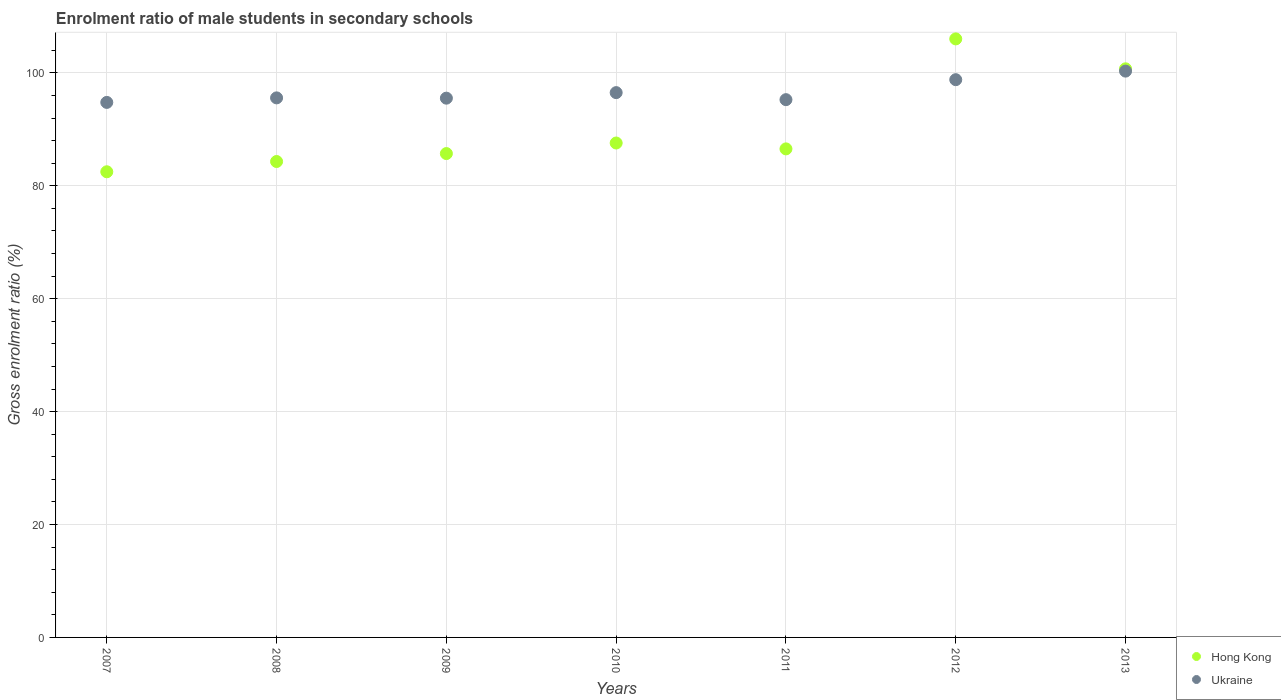Is the number of dotlines equal to the number of legend labels?
Provide a succinct answer. Yes. What is the enrolment ratio of male students in secondary schools in Hong Kong in 2007?
Keep it short and to the point. 82.49. Across all years, what is the maximum enrolment ratio of male students in secondary schools in Hong Kong?
Offer a terse response. 106.03. Across all years, what is the minimum enrolment ratio of male students in secondary schools in Hong Kong?
Give a very brief answer. 82.49. In which year was the enrolment ratio of male students in secondary schools in Hong Kong minimum?
Give a very brief answer. 2007. What is the total enrolment ratio of male students in secondary schools in Ukraine in the graph?
Provide a short and direct response. 676.79. What is the difference between the enrolment ratio of male students in secondary schools in Ukraine in 2010 and that in 2013?
Your answer should be compact. -3.81. What is the difference between the enrolment ratio of male students in secondary schools in Ukraine in 2008 and the enrolment ratio of male students in secondary schools in Hong Kong in 2010?
Give a very brief answer. 8. What is the average enrolment ratio of male students in secondary schools in Ukraine per year?
Give a very brief answer. 96.68. In the year 2010, what is the difference between the enrolment ratio of male students in secondary schools in Ukraine and enrolment ratio of male students in secondary schools in Hong Kong?
Offer a terse response. 8.93. What is the ratio of the enrolment ratio of male students in secondary schools in Hong Kong in 2009 to that in 2012?
Give a very brief answer. 0.81. Is the difference between the enrolment ratio of male students in secondary schools in Ukraine in 2008 and 2010 greater than the difference between the enrolment ratio of male students in secondary schools in Hong Kong in 2008 and 2010?
Your answer should be very brief. Yes. What is the difference between the highest and the second highest enrolment ratio of male students in secondary schools in Hong Kong?
Provide a succinct answer. 5.3. What is the difference between the highest and the lowest enrolment ratio of male students in secondary schools in Hong Kong?
Your answer should be very brief. 23.54. In how many years, is the enrolment ratio of male students in secondary schools in Hong Kong greater than the average enrolment ratio of male students in secondary schools in Hong Kong taken over all years?
Provide a short and direct response. 2. Does the enrolment ratio of male students in secondary schools in Ukraine monotonically increase over the years?
Ensure brevity in your answer.  No. Is the enrolment ratio of male students in secondary schools in Hong Kong strictly greater than the enrolment ratio of male students in secondary schools in Ukraine over the years?
Ensure brevity in your answer.  No. How many years are there in the graph?
Provide a succinct answer. 7. Does the graph contain any zero values?
Your answer should be compact. No. How are the legend labels stacked?
Give a very brief answer. Vertical. What is the title of the graph?
Give a very brief answer. Enrolment ratio of male students in secondary schools. Does "Least developed countries" appear as one of the legend labels in the graph?
Make the answer very short. No. What is the label or title of the X-axis?
Offer a terse response. Years. What is the label or title of the Y-axis?
Give a very brief answer. Gross enrolment ratio (%). What is the Gross enrolment ratio (%) in Hong Kong in 2007?
Give a very brief answer. 82.49. What is the Gross enrolment ratio (%) of Ukraine in 2007?
Provide a short and direct response. 94.78. What is the Gross enrolment ratio (%) in Hong Kong in 2008?
Offer a terse response. 84.31. What is the Gross enrolment ratio (%) of Ukraine in 2008?
Your answer should be compact. 95.58. What is the Gross enrolment ratio (%) of Hong Kong in 2009?
Make the answer very short. 85.72. What is the Gross enrolment ratio (%) of Ukraine in 2009?
Make the answer very short. 95.53. What is the Gross enrolment ratio (%) of Hong Kong in 2010?
Offer a terse response. 87.59. What is the Gross enrolment ratio (%) in Ukraine in 2010?
Offer a very short reply. 96.51. What is the Gross enrolment ratio (%) in Hong Kong in 2011?
Provide a short and direct response. 86.54. What is the Gross enrolment ratio (%) of Ukraine in 2011?
Provide a succinct answer. 95.26. What is the Gross enrolment ratio (%) of Hong Kong in 2012?
Your answer should be compact. 106.03. What is the Gross enrolment ratio (%) in Ukraine in 2012?
Provide a short and direct response. 98.8. What is the Gross enrolment ratio (%) in Hong Kong in 2013?
Ensure brevity in your answer.  100.73. What is the Gross enrolment ratio (%) of Ukraine in 2013?
Give a very brief answer. 100.32. Across all years, what is the maximum Gross enrolment ratio (%) in Hong Kong?
Provide a short and direct response. 106.03. Across all years, what is the maximum Gross enrolment ratio (%) in Ukraine?
Ensure brevity in your answer.  100.32. Across all years, what is the minimum Gross enrolment ratio (%) of Hong Kong?
Provide a succinct answer. 82.49. Across all years, what is the minimum Gross enrolment ratio (%) of Ukraine?
Your response must be concise. 94.78. What is the total Gross enrolment ratio (%) in Hong Kong in the graph?
Ensure brevity in your answer.  633.4. What is the total Gross enrolment ratio (%) in Ukraine in the graph?
Provide a succinct answer. 676.79. What is the difference between the Gross enrolment ratio (%) in Hong Kong in 2007 and that in 2008?
Give a very brief answer. -1.82. What is the difference between the Gross enrolment ratio (%) of Ukraine in 2007 and that in 2008?
Keep it short and to the point. -0.8. What is the difference between the Gross enrolment ratio (%) of Hong Kong in 2007 and that in 2009?
Ensure brevity in your answer.  -3.23. What is the difference between the Gross enrolment ratio (%) in Ukraine in 2007 and that in 2009?
Your answer should be very brief. -0.75. What is the difference between the Gross enrolment ratio (%) in Hong Kong in 2007 and that in 2010?
Give a very brief answer. -5.1. What is the difference between the Gross enrolment ratio (%) in Ukraine in 2007 and that in 2010?
Make the answer very short. -1.73. What is the difference between the Gross enrolment ratio (%) in Hong Kong in 2007 and that in 2011?
Keep it short and to the point. -4.05. What is the difference between the Gross enrolment ratio (%) in Ukraine in 2007 and that in 2011?
Make the answer very short. -0.49. What is the difference between the Gross enrolment ratio (%) in Hong Kong in 2007 and that in 2012?
Give a very brief answer. -23.54. What is the difference between the Gross enrolment ratio (%) of Ukraine in 2007 and that in 2012?
Offer a very short reply. -4.03. What is the difference between the Gross enrolment ratio (%) of Hong Kong in 2007 and that in 2013?
Your answer should be very brief. -18.24. What is the difference between the Gross enrolment ratio (%) of Ukraine in 2007 and that in 2013?
Your answer should be very brief. -5.54. What is the difference between the Gross enrolment ratio (%) of Hong Kong in 2008 and that in 2009?
Provide a short and direct response. -1.41. What is the difference between the Gross enrolment ratio (%) in Ukraine in 2008 and that in 2009?
Provide a succinct answer. 0.05. What is the difference between the Gross enrolment ratio (%) of Hong Kong in 2008 and that in 2010?
Give a very brief answer. -3.28. What is the difference between the Gross enrolment ratio (%) of Ukraine in 2008 and that in 2010?
Offer a very short reply. -0.93. What is the difference between the Gross enrolment ratio (%) of Hong Kong in 2008 and that in 2011?
Your answer should be very brief. -2.24. What is the difference between the Gross enrolment ratio (%) in Ukraine in 2008 and that in 2011?
Your answer should be compact. 0.32. What is the difference between the Gross enrolment ratio (%) in Hong Kong in 2008 and that in 2012?
Provide a succinct answer. -21.72. What is the difference between the Gross enrolment ratio (%) of Ukraine in 2008 and that in 2012?
Your response must be concise. -3.22. What is the difference between the Gross enrolment ratio (%) of Hong Kong in 2008 and that in 2013?
Make the answer very short. -16.42. What is the difference between the Gross enrolment ratio (%) of Ukraine in 2008 and that in 2013?
Provide a short and direct response. -4.74. What is the difference between the Gross enrolment ratio (%) in Hong Kong in 2009 and that in 2010?
Give a very brief answer. -1.87. What is the difference between the Gross enrolment ratio (%) of Ukraine in 2009 and that in 2010?
Your answer should be compact. -0.98. What is the difference between the Gross enrolment ratio (%) of Hong Kong in 2009 and that in 2011?
Make the answer very short. -0.83. What is the difference between the Gross enrolment ratio (%) in Ukraine in 2009 and that in 2011?
Your answer should be very brief. 0.26. What is the difference between the Gross enrolment ratio (%) in Hong Kong in 2009 and that in 2012?
Offer a very short reply. -20.31. What is the difference between the Gross enrolment ratio (%) of Ukraine in 2009 and that in 2012?
Your answer should be very brief. -3.28. What is the difference between the Gross enrolment ratio (%) of Hong Kong in 2009 and that in 2013?
Make the answer very short. -15.01. What is the difference between the Gross enrolment ratio (%) in Ukraine in 2009 and that in 2013?
Your response must be concise. -4.79. What is the difference between the Gross enrolment ratio (%) in Hong Kong in 2010 and that in 2011?
Give a very brief answer. 1.04. What is the difference between the Gross enrolment ratio (%) in Ukraine in 2010 and that in 2011?
Offer a terse response. 1.25. What is the difference between the Gross enrolment ratio (%) of Hong Kong in 2010 and that in 2012?
Give a very brief answer. -18.44. What is the difference between the Gross enrolment ratio (%) in Ukraine in 2010 and that in 2012?
Give a very brief answer. -2.29. What is the difference between the Gross enrolment ratio (%) in Hong Kong in 2010 and that in 2013?
Offer a terse response. -13.14. What is the difference between the Gross enrolment ratio (%) in Ukraine in 2010 and that in 2013?
Your answer should be very brief. -3.81. What is the difference between the Gross enrolment ratio (%) of Hong Kong in 2011 and that in 2012?
Your answer should be very brief. -19.49. What is the difference between the Gross enrolment ratio (%) of Ukraine in 2011 and that in 2012?
Give a very brief answer. -3.54. What is the difference between the Gross enrolment ratio (%) in Hong Kong in 2011 and that in 2013?
Keep it short and to the point. -14.18. What is the difference between the Gross enrolment ratio (%) in Ukraine in 2011 and that in 2013?
Your answer should be compact. -5.06. What is the difference between the Gross enrolment ratio (%) of Hong Kong in 2012 and that in 2013?
Your answer should be very brief. 5.3. What is the difference between the Gross enrolment ratio (%) of Ukraine in 2012 and that in 2013?
Ensure brevity in your answer.  -1.52. What is the difference between the Gross enrolment ratio (%) in Hong Kong in 2007 and the Gross enrolment ratio (%) in Ukraine in 2008?
Offer a very short reply. -13.09. What is the difference between the Gross enrolment ratio (%) in Hong Kong in 2007 and the Gross enrolment ratio (%) in Ukraine in 2009?
Offer a very short reply. -13.04. What is the difference between the Gross enrolment ratio (%) in Hong Kong in 2007 and the Gross enrolment ratio (%) in Ukraine in 2010?
Ensure brevity in your answer.  -14.02. What is the difference between the Gross enrolment ratio (%) in Hong Kong in 2007 and the Gross enrolment ratio (%) in Ukraine in 2011?
Provide a succinct answer. -12.77. What is the difference between the Gross enrolment ratio (%) of Hong Kong in 2007 and the Gross enrolment ratio (%) of Ukraine in 2012?
Offer a terse response. -16.31. What is the difference between the Gross enrolment ratio (%) in Hong Kong in 2007 and the Gross enrolment ratio (%) in Ukraine in 2013?
Keep it short and to the point. -17.83. What is the difference between the Gross enrolment ratio (%) of Hong Kong in 2008 and the Gross enrolment ratio (%) of Ukraine in 2009?
Offer a very short reply. -11.22. What is the difference between the Gross enrolment ratio (%) in Hong Kong in 2008 and the Gross enrolment ratio (%) in Ukraine in 2010?
Your answer should be compact. -12.2. What is the difference between the Gross enrolment ratio (%) of Hong Kong in 2008 and the Gross enrolment ratio (%) of Ukraine in 2011?
Keep it short and to the point. -10.96. What is the difference between the Gross enrolment ratio (%) of Hong Kong in 2008 and the Gross enrolment ratio (%) of Ukraine in 2012?
Provide a succinct answer. -14.5. What is the difference between the Gross enrolment ratio (%) in Hong Kong in 2008 and the Gross enrolment ratio (%) in Ukraine in 2013?
Your answer should be compact. -16.01. What is the difference between the Gross enrolment ratio (%) of Hong Kong in 2009 and the Gross enrolment ratio (%) of Ukraine in 2010?
Provide a short and direct response. -10.8. What is the difference between the Gross enrolment ratio (%) in Hong Kong in 2009 and the Gross enrolment ratio (%) in Ukraine in 2011?
Provide a succinct answer. -9.55. What is the difference between the Gross enrolment ratio (%) in Hong Kong in 2009 and the Gross enrolment ratio (%) in Ukraine in 2012?
Your answer should be very brief. -13.09. What is the difference between the Gross enrolment ratio (%) of Hong Kong in 2009 and the Gross enrolment ratio (%) of Ukraine in 2013?
Provide a succinct answer. -14.6. What is the difference between the Gross enrolment ratio (%) in Hong Kong in 2010 and the Gross enrolment ratio (%) in Ukraine in 2011?
Make the answer very short. -7.68. What is the difference between the Gross enrolment ratio (%) of Hong Kong in 2010 and the Gross enrolment ratio (%) of Ukraine in 2012?
Provide a succinct answer. -11.22. What is the difference between the Gross enrolment ratio (%) of Hong Kong in 2010 and the Gross enrolment ratio (%) of Ukraine in 2013?
Your response must be concise. -12.73. What is the difference between the Gross enrolment ratio (%) of Hong Kong in 2011 and the Gross enrolment ratio (%) of Ukraine in 2012?
Provide a succinct answer. -12.26. What is the difference between the Gross enrolment ratio (%) of Hong Kong in 2011 and the Gross enrolment ratio (%) of Ukraine in 2013?
Ensure brevity in your answer.  -13.78. What is the difference between the Gross enrolment ratio (%) in Hong Kong in 2012 and the Gross enrolment ratio (%) in Ukraine in 2013?
Offer a terse response. 5.71. What is the average Gross enrolment ratio (%) in Hong Kong per year?
Offer a terse response. 90.49. What is the average Gross enrolment ratio (%) in Ukraine per year?
Offer a very short reply. 96.68. In the year 2007, what is the difference between the Gross enrolment ratio (%) in Hong Kong and Gross enrolment ratio (%) in Ukraine?
Make the answer very short. -12.29. In the year 2008, what is the difference between the Gross enrolment ratio (%) of Hong Kong and Gross enrolment ratio (%) of Ukraine?
Give a very brief answer. -11.27. In the year 2009, what is the difference between the Gross enrolment ratio (%) in Hong Kong and Gross enrolment ratio (%) in Ukraine?
Provide a short and direct response. -9.81. In the year 2010, what is the difference between the Gross enrolment ratio (%) in Hong Kong and Gross enrolment ratio (%) in Ukraine?
Offer a very short reply. -8.93. In the year 2011, what is the difference between the Gross enrolment ratio (%) in Hong Kong and Gross enrolment ratio (%) in Ukraine?
Provide a succinct answer. -8.72. In the year 2012, what is the difference between the Gross enrolment ratio (%) in Hong Kong and Gross enrolment ratio (%) in Ukraine?
Your response must be concise. 7.23. In the year 2013, what is the difference between the Gross enrolment ratio (%) of Hong Kong and Gross enrolment ratio (%) of Ukraine?
Your answer should be very brief. 0.41. What is the ratio of the Gross enrolment ratio (%) of Hong Kong in 2007 to that in 2008?
Keep it short and to the point. 0.98. What is the ratio of the Gross enrolment ratio (%) in Ukraine in 2007 to that in 2008?
Ensure brevity in your answer.  0.99. What is the ratio of the Gross enrolment ratio (%) of Hong Kong in 2007 to that in 2009?
Your answer should be compact. 0.96. What is the ratio of the Gross enrolment ratio (%) of Ukraine in 2007 to that in 2009?
Give a very brief answer. 0.99. What is the ratio of the Gross enrolment ratio (%) in Hong Kong in 2007 to that in 2010?
Your response must be concise. 0.94. What is the ratio of the Gross enrolment ratio (%) in Ukraine in 2007 to that in 2010?
Your answer should be very brief. 0.98. What is the ratio of the Gross enrolment ratio (%) in Hong Kong in 2007 to that in 2011?
Keep it short and to the point. 0.95. What is the ratio of the Gross enrolment ratio (%) in Ukraine in 2007 to that in 2011?
Offer a very short reply. 0.99. What is the ratio of the Gross enrolment ratio (%) in Hong Kong in 2007 to that in 2012?
Keep it short and to the point. 0.78. What is the ratio of the Gross enrolment ratio (%) in Ukraine in 2007 to that in 2012?
Provide a succinct answer. 0.96. What is the ratio of the Gross enrolment ratio (%) of Hong Kong in 2007 to that in 2013?
Keep it short and to the point. 0.82. What is the ratio of the Gross enrolment ratio (%) of Ukraine in 2007 to that in 2013?
Make the answer very short. 0.94. What is the ratio of the Gross enrolment ratio (%) in Hong Kong in 2008 to that in 2009?
Provide a short and direct response. 0.98. What is the ratio of the Gross enrolment ratio (%) in Ukraine in 2008 to that in 2009?
Provide a short and direct response. 1. What is the ratio of the Gross enrolment ratio (%) in Hong Kong in 2008 to that in 2010?
Your answer should be very brief. 0.96. What is the ratio of the Gross enrolment ratio (%) of Ukraine in 2008 to that in 2010?
Ensure brevity in your answer.  0.99. What is the ratio of the Gross enrolment ratio (%) of Hong Kong in 2008 to that in 2011?
Ensure brevity in your answer.  0.97. What is the ratio of the Gross enrolment ratio (%) in Ukraine in 2008 to that in 2011?
Give a very brief answer. 1. What is the ratio of the Gross enrolment ratio (%) in Hong Kong in 2008 to that in 2012?
Offer a terse response. 0.8. What is the ratio of the Gross enrolment ratio (%) of Ukraine in 2008 to that in 2012?
Offer a very short reply. 0.97. What is the ratio of the Gross enrolment ratio (%) of Hong Kong in 2008 to that in 2013?
Your answer should be compact. 0.84. What is the ratio of the Gross enrolment ratio (%) of Ukraine in 2008 to that in 2013?
Give a very brief answer. 0.95. What is the ratio of the Gross enrolment ratio (%) in Hong Kong in 2009 to that in 2010?
Ensure brevity in your answer.  0.98. What is the ratio of the Gross enrolment ratio (%) in Hong Kong in 2009 to that in 2012?
Provide a succinct answer. 0.81. What is the ratio of the Gross enrolment ratio (%) in Ukraine in 2009 to that in 2012?
Keep it short and to the point. 0.97. What is the ratio of the Gross enrolment ratio (%) in Hong Kong in 2009 to that in 2013?
Offer a terse response. 0.85. What is the ratio of the Gross enrolment ratio (%) of Ukraine in 2009 to that in 2013?
Offer a terse response. 0.95. What is the ratio of the Gross enrolment ratio (%) in Hong Kong in 2010 to that in 2011?
Your answer should be compact. 1.01. What is the ratio of the Gross enrolment ratio (%) in Ukraine in 2010 to that in 2011?
Offer a terse response. 1.01. What is the ratio of the Gross enrolment ratio (%) in Hong Kong in 2010 to that in 2012?
Your response must be concise. 0.83. What is the ratio of the Gross enrolment ratio (%) of Ukraine in 2010 to that in 2012?
Give a very brief answer. 0.98. What is the ratio of the Gross enrolment ratio (%) in Hong Kong in 2010 to that in 2013?
Provide a succinct answer. 0.87. What is the ratio of the Gross enrolment ratio (%) of Hong Kong in 2011 to that in 2012?
Your response must be concise. 0.82. What is the ratio of the Gross enrolment ratio (%) of Ukraine in 2011 to that in 2012?
Make the answer very short. 0.96. What is the ratio of the Gross enrolment ratio (%) of Hong Kong in 2011 to that in 2013?
Your answer should be very brief. 0.86. What is the ratio of the Gross enrolment ratio (%) of Ukraine in 2011 to that in 2013?
Provide a short and direct response. 0.95. What is the ratio of the Gross enrolment ratio (%) in Hong Kong in 2012 to that in 2013?
Your response must be concise. 1.05. What is the ratio of the Gross enrolment ratio (%) of Ukraine in 2012 to that in 2013?
Offer a terse response. 0.98. What is the difference between the highest and the second highest Gross enrolment ratio (%) of Hong Kong?
Offer a terse response. 5.3. What is the difference between the highest and the second highest Gross enrolment ratio (%) in Ukraine?
Keep it short and to the point. 1.52. What is the difference between the highest and the lowest Gross enrolment ratio (%) in Hong Kong?
Give a very brief answer. 23.54. What is the difference between the highest and the lowest Gross enrolment ratio (%) in Ukraine?
Offer a very short reply. 5.54. 